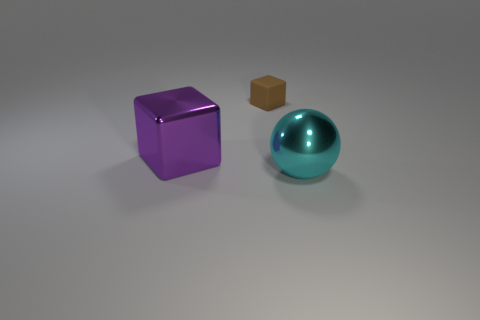Add 1 purple cubes. How many objects exist? 4 Subtract all blocks. How many objects are left? 1 Subtract 0 cyan cylinders. How many objects are left? 3 Subtract all cyan balls. Subtract all brown rubber cubes. How many objects are left? 1 Add 3 small matte blocks. How many small matte blocks are left? 4 Add 1 brown objects. How many brown objects exist? 2 